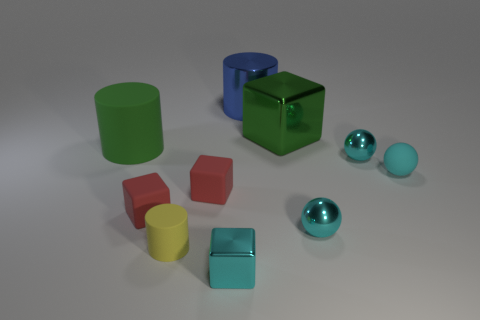How many matte objects are large green cylinders or yellow objects?
Give a very brief answer. 2. What is the size of the matte thing that is to the left of the large metal cube and on the right side of the tiny cylinder?
Ensure brevity in your answer.  Small. Is there a matte ball that is on the left side of the metallic block that is behind the small yellow object?
Offer a very short reply. No. There is a big green matte thing; how many red matte blocks are on the left side of it?
Ensure brevity in your answer.  0. There is a big metal thing that is the same shape as the small yellow rubber object; what is its color?
Offer a terse response. Blue. Is the material of the small cyan object behind the cyan matte ball the same as the tiny sphere in front of the tiny rubber sphere?
Keep it short and to the point. Yes. Do the large metal cylinder and the object in front of the tiny yellow rubber cylinder have the same color?
Your response must be concise. No. The big thing that is both on the left side of the green metallic cube and to the right of the big green cylinder has what shape?
Ensure brevity in your answer.  Cylinder. What number of balls are there?
Keep it short and to the point. 3. What is the shape of the large matte thing that is the same color as the big block?
Offer a very short reply. Cylinder. 